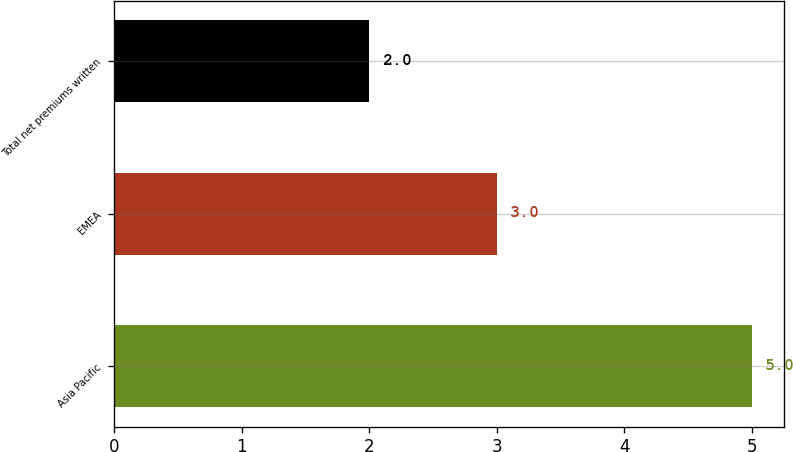<chart> <loc_0><loc_0><loc_500><loc_500><bar_chart><fcel>Asia Pacific<fcel>EMEA<fcel>Total net premiums written<nl><fcel>5<fcel>3<fcel>2<nl></chart> 